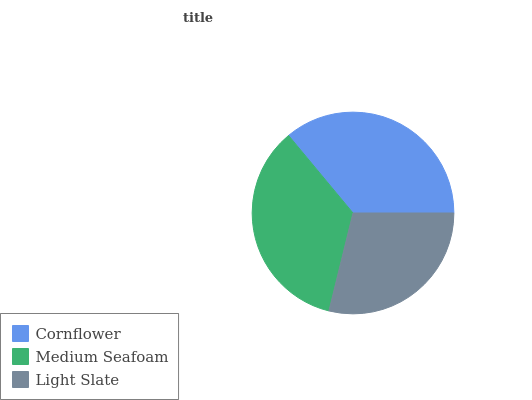Is Light Slate the minimum?
Answer yes or no. Yes. Is Cornflower the maximum?
Answer yes or no. Yes. Is Medium Seafoam the minimum?
Answer yes or no. No. Is Medium Seafoam the maximum?
Answer yes or no. No. Is Cornflower greater than Medium Seafoam?
Answer yes or no. Yes. Is Medium Seafoam less than Cornflower?
Answer yes or no. Yes. Is Medium Seafoam greater than Cornflower?
Answer yes or no. No. Is Cornflower less than Medium Seafoam?
Answer yes or no. No. Is Medium Seafoam the high median?
Answer yes or no. Yes. Is Medium Seafoam the low median?
Answer yes or no. Yes. Is Cornflower the high median?
Answer yes or no. No. Is Cornflower the low median?
Answer yes or no. No. 